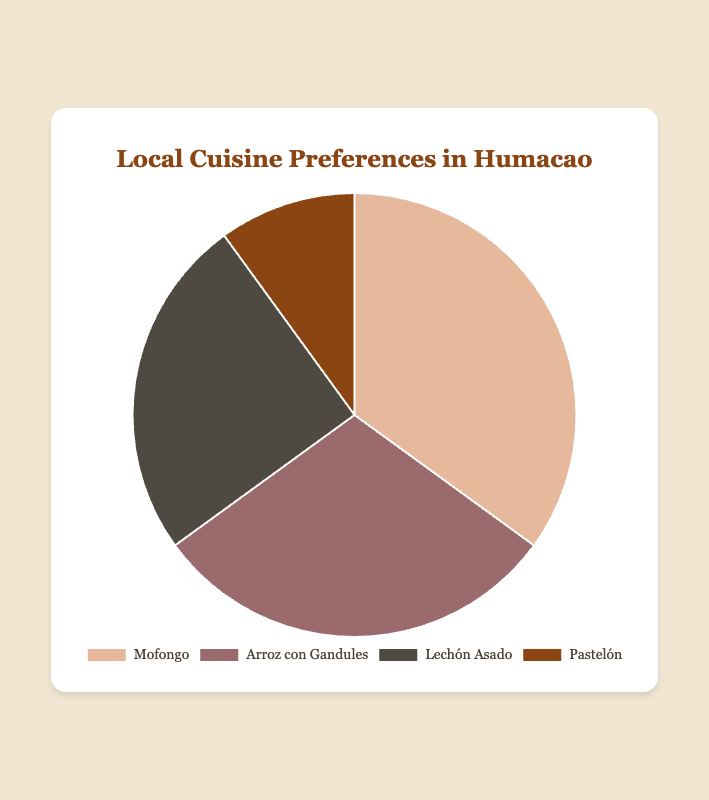What percentage of people prefer Mofongo? The pie chart indicates the percentage of people who prefer various local cuisines. According to the chart, Mofongo is preferred by 35% of the people.
Answer: 35% Which dish is the least preferred? By looking at the pie chart, it is clear that Pastelón has the smallest section, indicating it is the least preferred dish among the local cuisines listed, with a preference percentage of 10%.
Answer: Pastelón How much more popular is Mofongo than Lechón Asado? To find out how much more popular Mofongo is compared to Lechón Asado, subtract the preference percentage of Lechón Asado from that of Mofongo: 35% - 25% = 10%.
Answer: 10% What's the combined preference percentage of Arroz con Gandules and Lechón Asado? To determine the combined preference percentage, add the preference percentages of Arroz con Gandules and Lechón Asado. The chart shows 30% for Arroz con Gandules and 25% for Lechón Asado: 30% + 25% = 55%.
Answer: 55% Which two dishes have a combined preference percentage equal to 60%? To find which two dishes have a combined preference of 60%, look for combinations in the pie chart data. The combined preferences of Mofongo (35%) and Pastelón (10%) do not equal 60%. However, Arroz con Gandules (30%) and Lechón Asado (25%) also don't add up to 60%. Therefore, adding Mofongo (35%) and Lechón Asado (25%) equals 60%.
Answer: Mofongo and Lechón Asado Which cuisine has a dark color slice nearest to brown in the pie chart? Observing the color coding in the pie chart, Lechón Asado is represented with the darkest shade, nearest to brown.
Answer: Lechón Asado What fraction of people prefer either Arroz con Gandules or Pastelón? To find the fraction of people who prefer either Arroz con Gandules or Pastelón, add their percentages and then convert to a fraction: 30% + 10% = 40%. As a fraction, this is 40/100, which simplifies to 2/5.
Answer: 2/5 Is the sum of the preference percentages for Mofongo and Pastelón more than 40%? To check whether the sum is more than 40%, add the preference percentages of Mofongo and Pastelón shown in the pie chart: 35% (Mofongo) + 10% (Pastelón) = 45%. Since 45% is greater than 40%, the sum is indeed more than 40%.
Answer: Yes 